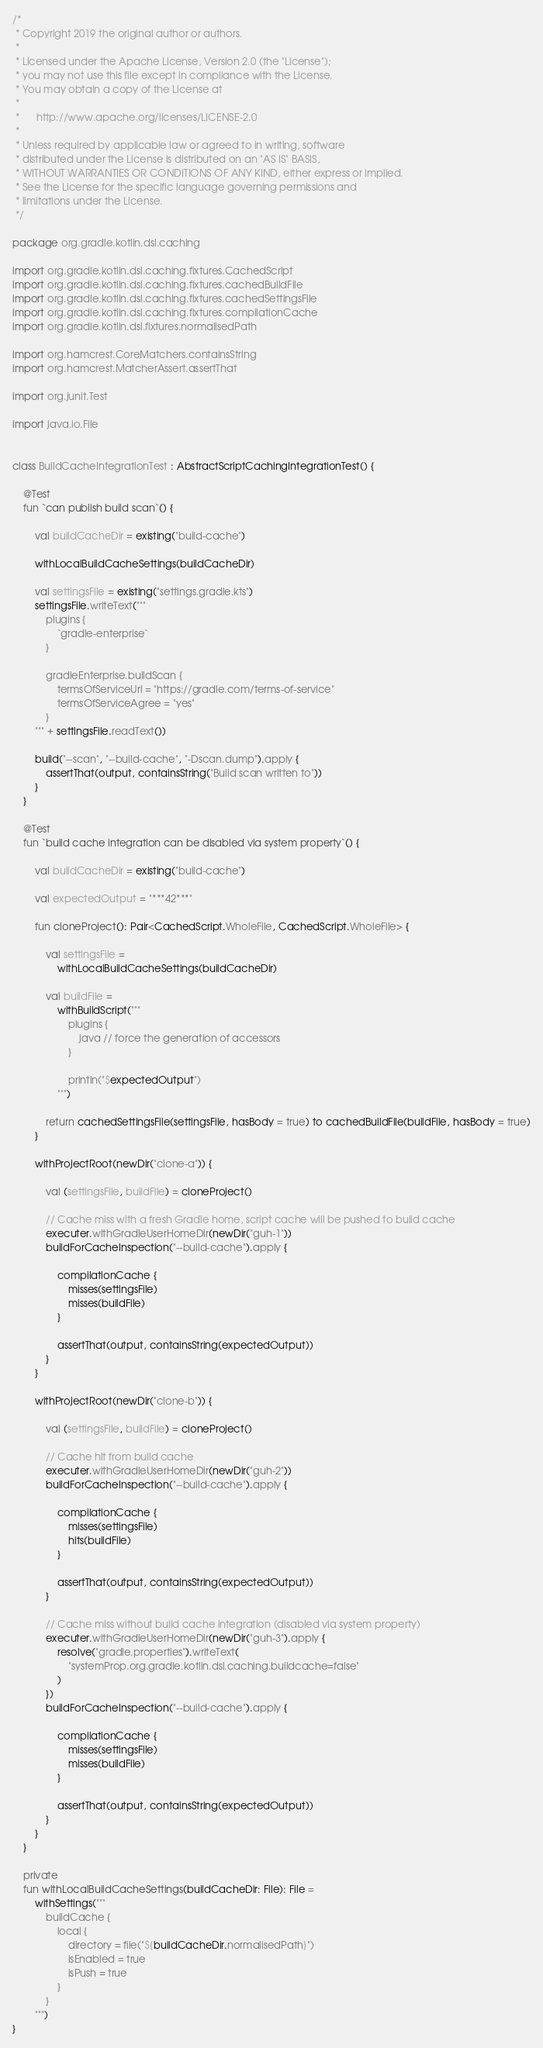<code> <loc_0><loc_0><loc_500><loc_500><_Kotlin_>/*
 * Copyright 2019 the original author or authors.
 *
 * Licensed under the Apache License, Version 2.0 (the "License");
 * you may not use this file except in compliance with the License.
 * You may obtain a copy of the License at
 *
 *      http://www.apache.org/licenses/LICENSE-2.0
 *
 * Unless required by applicable law or agreed to in writing, software
 * distributed under the License is distributed on an "AS IS" BASIS,
 * WITHOUT WARRANTIES OR CONDITIONS OF ANY KIND, either express or implied.
 * See the License for the specific language governing permissions and
 * limitations under the License.
 */

package org.gradle.kotlin.dsl.caching

import org.gradle.kotlin.dsl.caching.fixtures.CachedScript
import org.gradle.kotlin.dsl.caching.fixtures.cachedBuildFile
import org.gradle.kotlin.dsl.caching.fixtures.cachedSettingsFile
import org.gradle.kotlin.dsl.caching.fixtures.compilationCache
import org.gradle.kotlin.dsl.fixtures.normalisedPath

import org.hamcrest.CoreMatchers.containsString
import org.hamcrest.MatcherAssert.assertThat

import org.junit.Test

import java.io.File


class BuildCacheIntegrationTest : AbstractScriptCachingIntegrationTest() {

    @Test
    fun `can publish build scan`() {

        val buildCacheDir = existing("build-cache")

        withLocalBuildCacheSettings(buildCacheDir)

        val settingsFile = existing("settings.gradle.kts")
        settingsFile.writeText("""
            plugins {
                `gradle-enterprise`
            }

            gradleEnterprise.buildScan {
                termsOfServiceUrl = "https://gradle.com/terms-of-service"
                termsOfServiceAgree = "yes"
            }
        """ + settingsFile.readText())

        build("--scan", "--build-cache", "-Dscan.dump").apply {
            assertThat(output, containsString("Build scan written to"))
        }
    }

    @Test
    fun `build cache integration can be disabled via system property`() {

        val buildCacheDir = existing("build-cache")

        val expectedOutput = "***42***"

        fun cloneProject(): Pair<CachedScript.WholeFile, CachedScript.WholeFile> {

            val settingsFile =
                withLocalBuildCacheSettings(buildCacheDir)

            val buildFile =
                withBuildScript("""
                    plugins {
                        java // force the generation of accessors
                    }

                    println("$expectedOutput")
                """)

            return cachedSettingsFile(settingsFile, hasBody = true) to cachedBuildFile(buildFile, hasBody = true)
        }

        withProjectRoot(newDir("clone-a")) {

            val (settingsFile, buildFile) = cloneProject()

            // Cache miss with a fresh Gradle home, script cache will be pushed to build cache
            executer.withGradleUserHomeDir(newDir("guh-1"))
            buildForCacheInspection("--build-cache").apply {

                compilationCache {
                    misses(settingsFile)
                    misses(buildFile)
                }

                assertThat(output, containsString(expectedOutput))
            }
        }

        withProjectRoot(newDir("clone-b")) {

            val (settingsFile, buildFile) = cloneProject()

            // Cache hit from build cache
            executer.withGradleUserHomeDir(newDir("guh-2"))
            buildForCacheInspection("--build-cache").apply {

                compilationCache {
                    misses(settingsFile)
                    hits(buildFile)
                }

                assertThat(output, containsString(expectedOutput))
            }

            // Cache miss without build cache integration (disabled via system property)
            executer.withGradleUserHomeDir(newDir("guh-3").apply {
                resolve("gradle.properties").writeText(
                    "systemProp.org.gradle.kotlin.dsl.caching.buildcache=false"
                )
            })
            buildForCacheInspection("--build-cache").apply {

                compilationCache {
                    misses(settingsFile)
                    misses(buildFile)
                }

                assertThat(output, containsString(expectedOutput))
            }
        }
    }

    private
    fun withLocalBuildCacheSettings(buildCacheDir: File): File =
        withSettings("""
            buildCache {
                local {
                    directory = file("${buildCacheDir.normalisedPath}")
                    isEnabled = true
                    isPush = true
                }
            }
        """)
}
</code> 